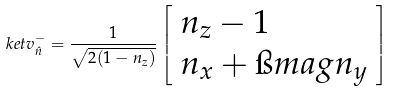<formula> <loc_0><loc_0><loc_500><loc_500>\ k e t { v _ { \hat { n } } ^ { - } } = \frac { 1 } { \sqrt { 2 ( 1 - n _ { z } ) } } \left [ \begin{array} { l } n _ { z } - 1 \\ n _ { x } + \i m a g n _ { y } \\ \end{array} \right ]</formula> 